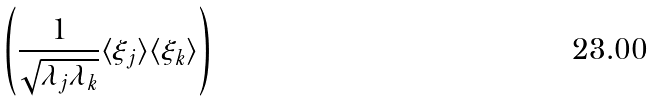<formula> <loc_0><loc_0><loc_500><loc_500>\left ( \frac { 1 } { \sqrt { \lambda _ { j } \lambda _ { k } } } \langle \xi _ { j } \rangle \langle \xi _ { k } \rangle \right )</formula> 